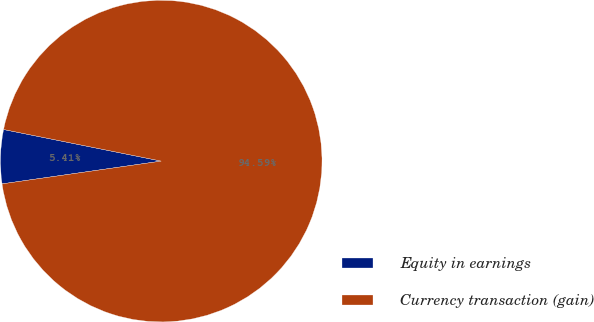Convert chart. <chart><loc_0><loc_0><loc_500><loc_500><pie_chart><fcel>Equity in earnings<fcel>Currency transaction (gain)<nl><fcel>5.41%<fcel>94.59%<nl></chart> 